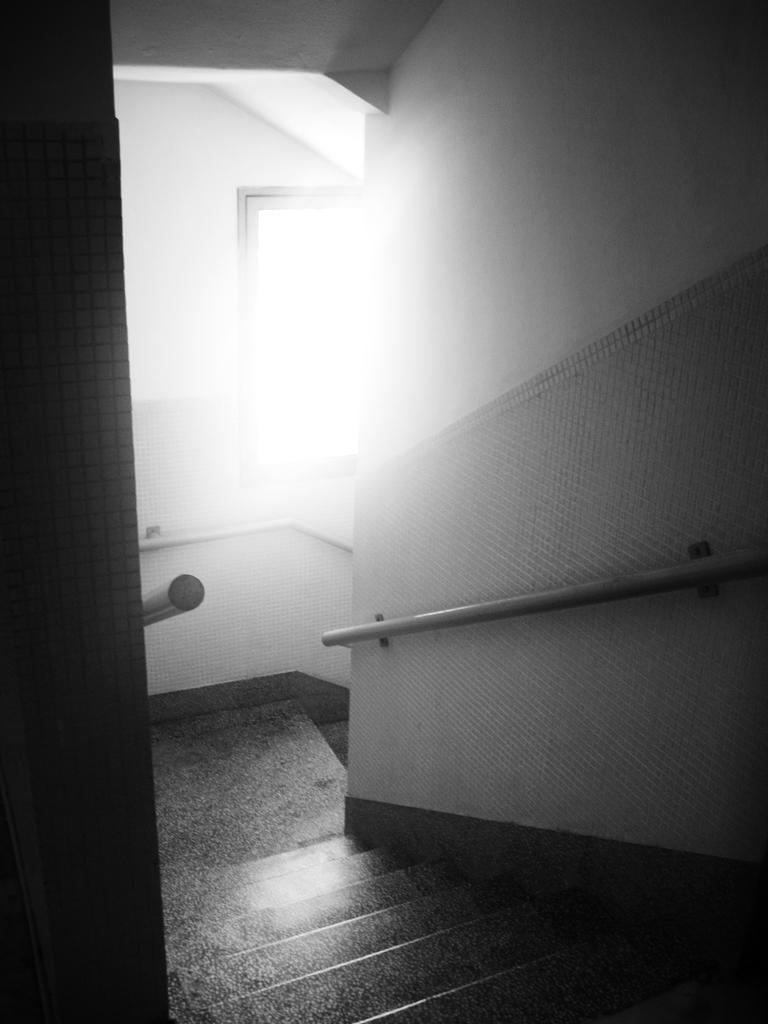Describe this image in one or two sentences. This is a black and white picture of a staircase with a window in the back. 